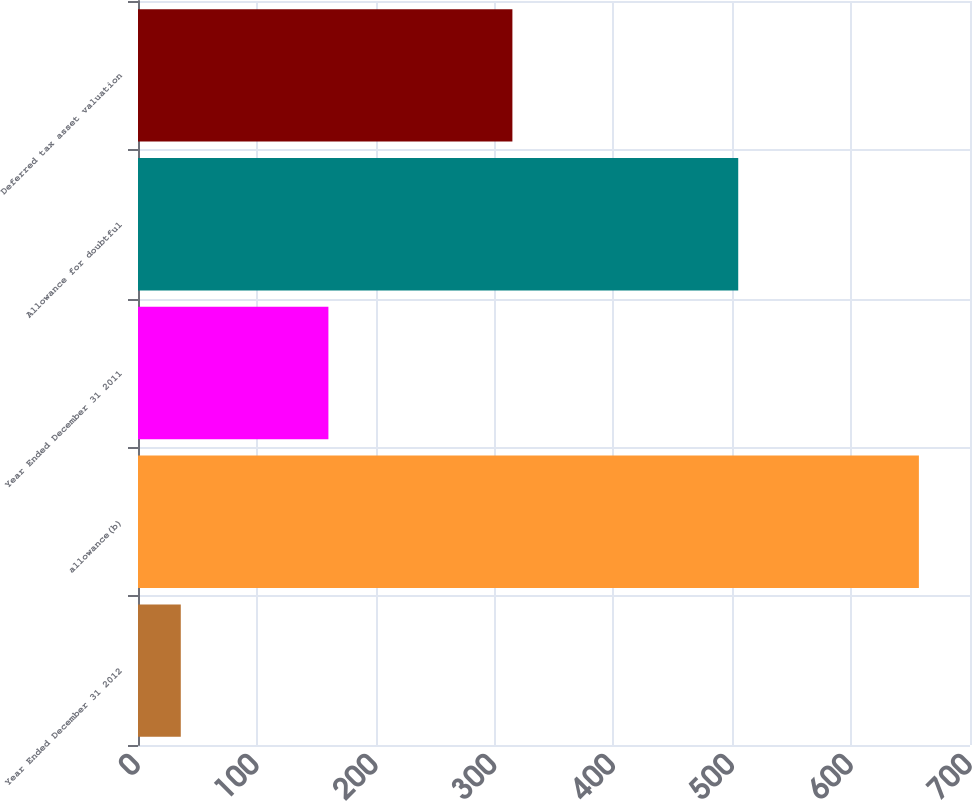Convert chart. <chart><loc_0><loc_0><loc_500><loc_500><bar_chart><fcel>Year Ended December 31 2012<fcel>allowance(b)<fcel>Year Ended December 31 2011<fcel>Allowance for doubtful<fcel>Deferred tax asset valuation<nl><fcel>36<fcel>657<fcel>160.2<fcel>505<fcel>315<nl></chart> 